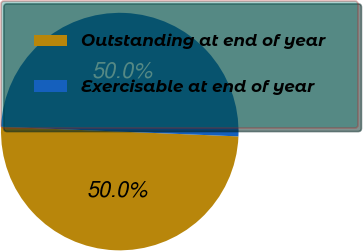Convert chart to OTSL. <chart><loc_0><loc_0><loc_500><loc_500><pie_chart><fcel>Outstanding at end of year<fcel>Exercisable at end of year<nl><fcel>50.0%<fcel>50.0%<nl></chart> 